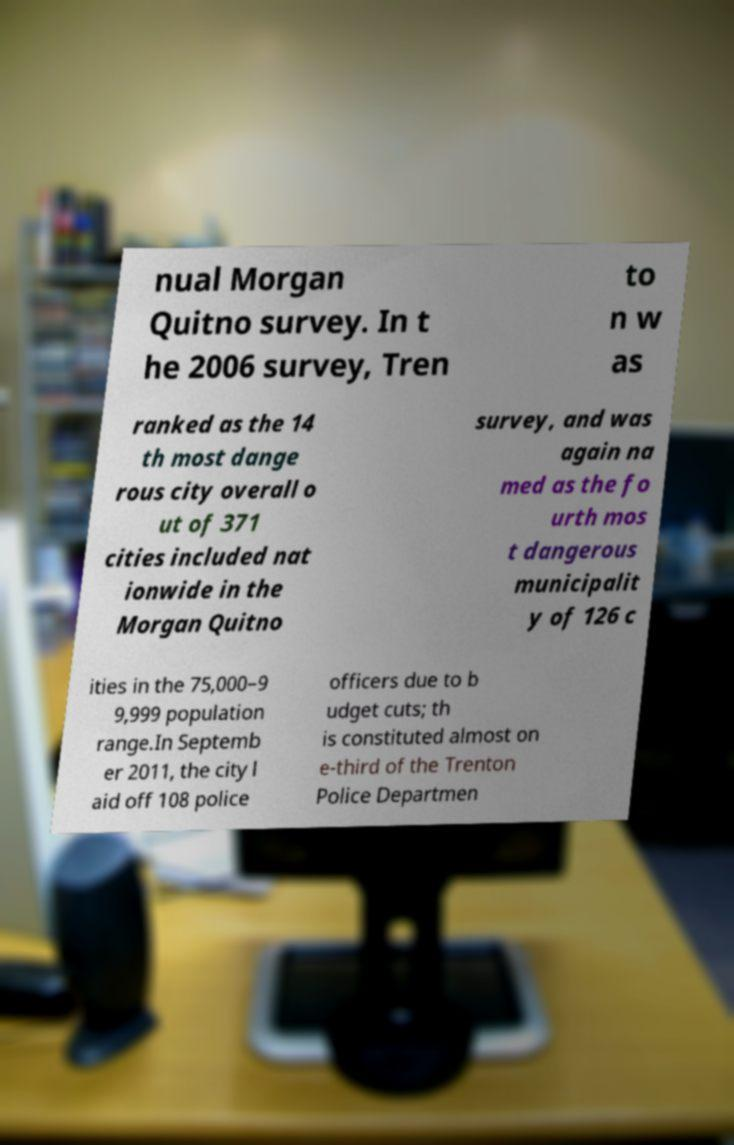Could you extract and type out the text from this image? nual Morgan Quitno survey. In t he 2006 survey, Tren to n w as ranked as the 14 th most dange rous city overall o ut of 371 cities included nat ionwide in the Morgan Quitno survey, and was again na med as the fo urth mos t dangerous municipalit y of 126 c ities in the 75,000–9 9,999 population range.In Septemb er 2011, the city l aid off 108 police officers due to b udget cuts; th is constituted almost on e-third of the Trenton Police Departmen 